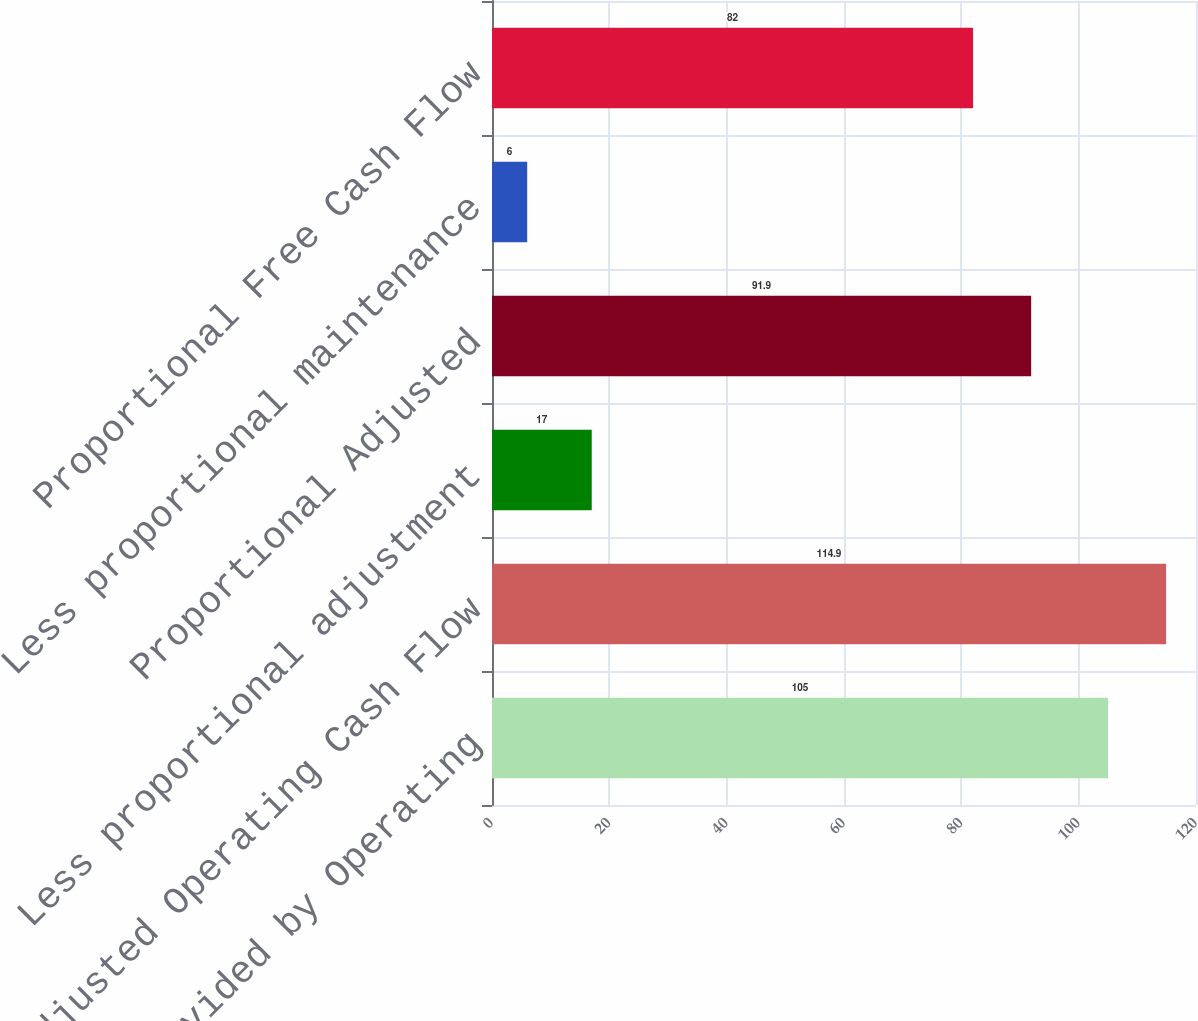Convert chart to OTSL. <chart><loc_0><loc_0><loc_500><loc_500><bar_chart><fcel>Net Cash Provided by Operating<fcel>Adjusted Operating Cash Flow<fcel>Less proportional adjustment<fcel>Proportional Adjusted<fcel>Less proportional maintenance<fcel>Proportional Free Cash Flow<nl><fcel>105<fcel>114.9<fcel>17<fcel>91.9<fcel>6<fcel>82<nl></chart> 